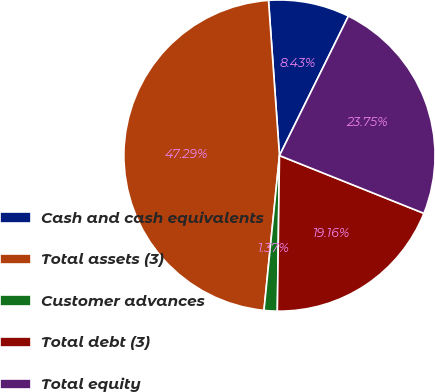Convert chart to OTSL. <chart><loc_0><loc_0><loc_500><loc_500><pie_chart><fcel>Cash and cash equivalents<fcel>Total assets (3)<fcel>Customer advances<fcel>Total debt (3)<fcel>Total equity<nl><fcel>8.43%<fcel>47.29%<fcel>1.37%<fcel>19.16%<fcel>23.75%<nl></chart> 